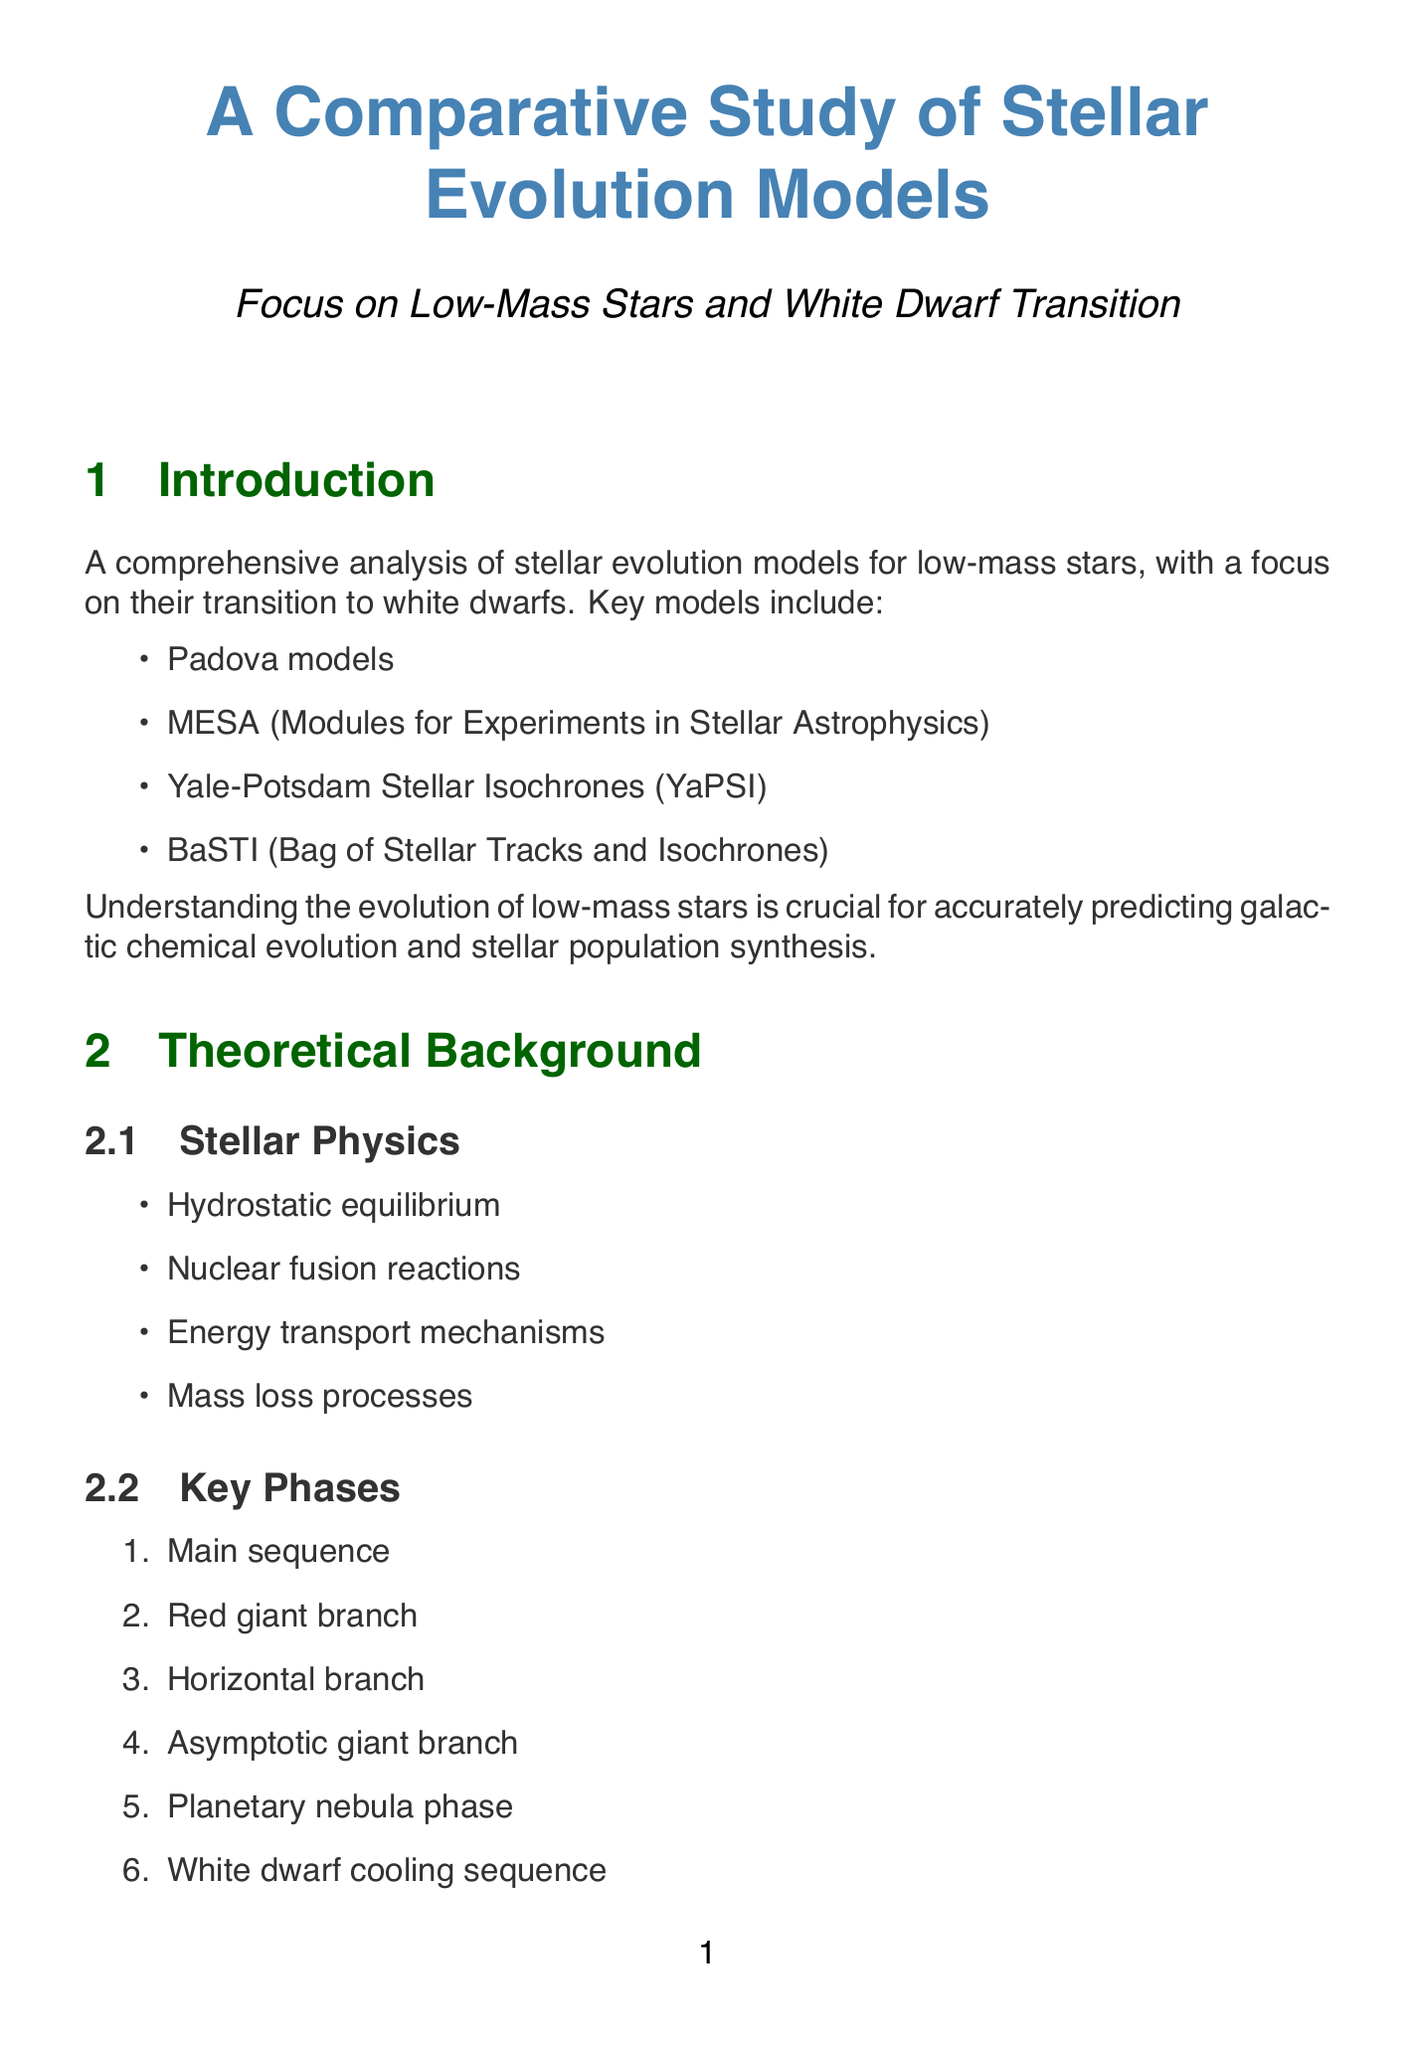What are the key models analyzed in the study? The key models are listed in the introduction as those used for comparing stellar evolution of low-mass stars.
Answer: Padova models, MESA, YaPSI, BaSTI What is a limitation of the Padova models? Limitations of the Padova models are detailed in the model comparison section, highlighting their drawbacks.
Answer: Limited flexibility in input physics Which observational constraints are mentioned related to white dwarf transition? The document lists observational constraints in the white dwarf transition section, indicating important aspects studied.
Answer: Initial-final mass relation, White dwarf luminosity function, Planetary nebulae luminosity function How does MESA's mass-loss treatment differ from Padova's? MESA offers customizable mass-loss prescriptions, allowing for more variety compared to Padova’s approach, as specified in the white dwarf transition section.
Answer: Customizable mass-loss prescriptions What future research area is suggested regarding mixing processes? The future directions section proposes specific research areas for further investigation, indicating future possibilities in stellar evolution studies.
Answer: Better understanding of mixing processes in stellar interiors Which upcoming observatory will study evolved stars in the infrared? The upcoming observatories section identifies specific missions aimed at different aspects of stellar evolution research.
Answer: James Webb Space Telescope (JWST) What is one recent advancement in observational breakthroughs? The recent advancements section mentions notable breakthroughs, showcasing new developments in observational capabilities in stellar research.
Answer: Gaia mission providing precise parallaxes and proper motions Which stellar phase comes after the horizontal branch? The key phases of stellar evolution are listed in a specific order, highlighting the transitions during stellar life cycles.
Answer: Asymptotic giant branch 